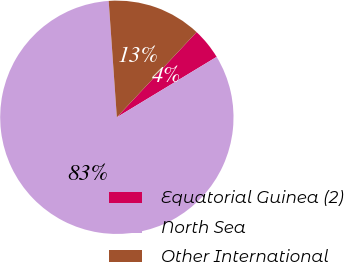Convert chart. <chart><loc_0><loc_0><loc_500><loc_500><pie_chart><fcel>Equatorial Guinea (2)<fcel>North Sea<fcel>Other International<nl><fcel>4.36%<fcel>82.55%<fcel>13.09%<nl></chart> 